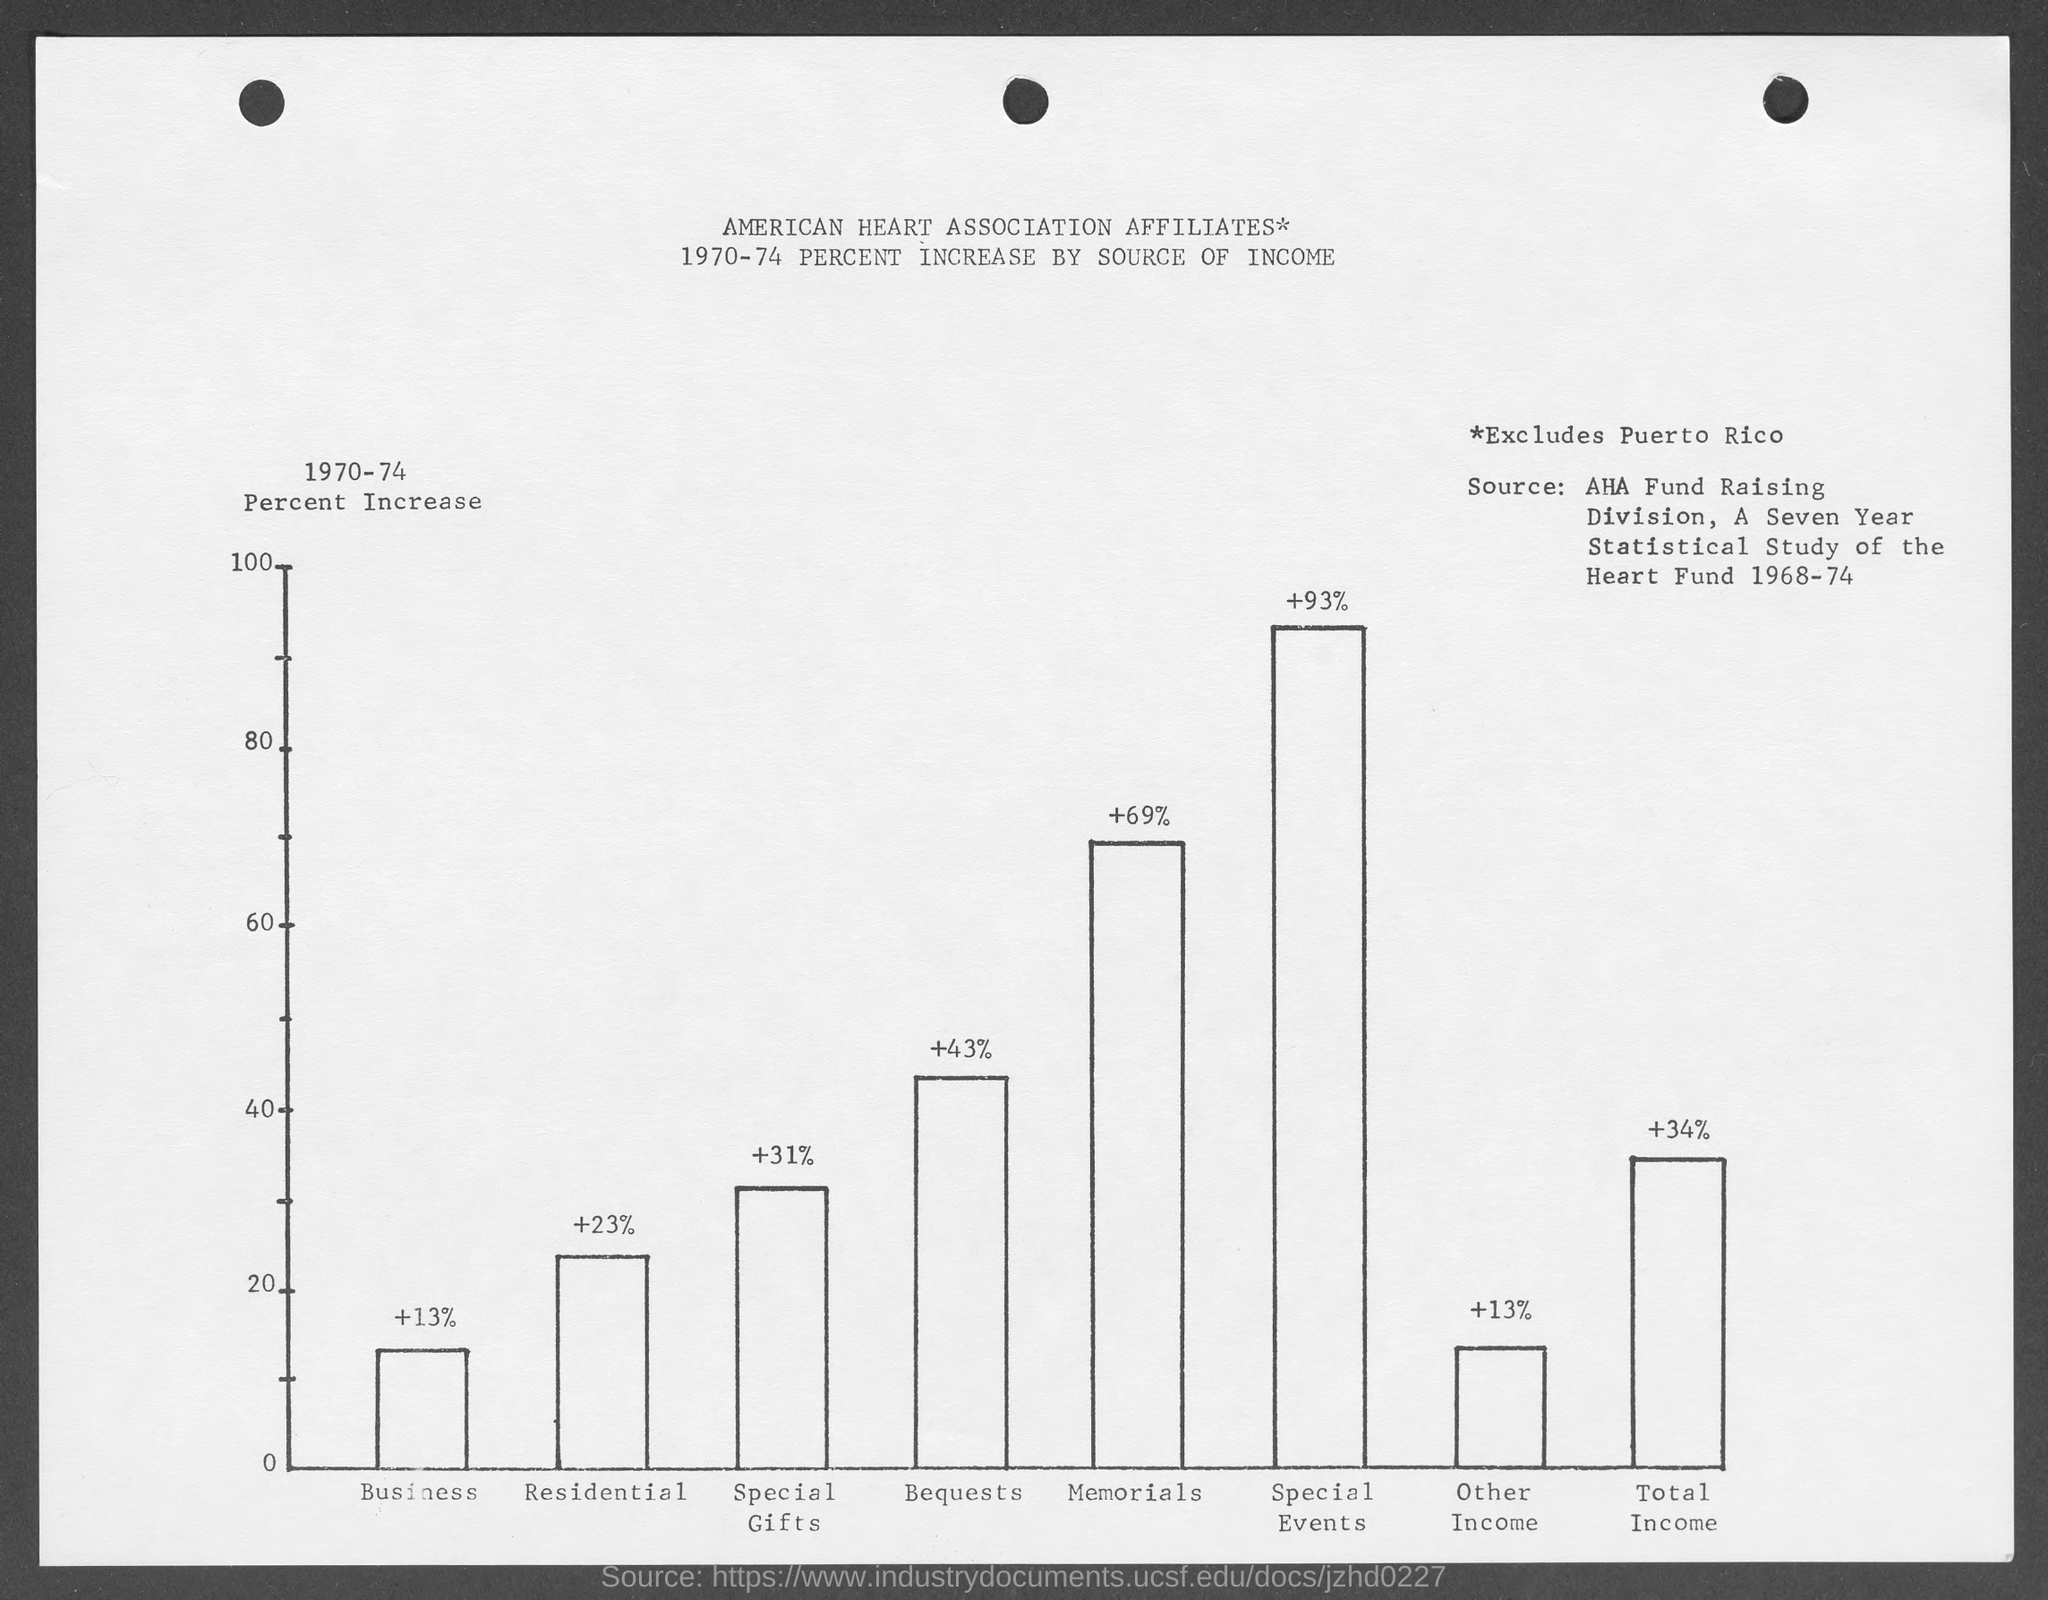What is the percentage increase by source of income of business from 1970-74 mentioned in the given graph ?
Offer a terse response. +13%. What is the percentage increase by source of income of residential from 1970-74 mentioned in the given graph ?
Your answer should be very brief. + 23 %. What is the percentage increase by source of income of special gifts from 1970-74 mentioned in the given graph ?
Offer a terse response. 31. What is the percentage increase by source of bequests  of business from 1970-74 mentioned in the given graph ?
Give a very brief answer. 43. What is the percentage increase by source of memorials of business from 1970-74 mentioned in the given graph ?
Offer a very short reply. + 69%. What is the percentage increase by source of special events of business from 1970-74 mentioned in the given graph ?
Offer a terse response. +93%. What is the percentage increase by source of other income  of business from 1970-74 mentioned in the given graph ?
Make the answer very short. 13. What is the percentage increase by source of total income  of business from 1970-74 mentioned in the given graph ?
Keep it short and to the point. +34%. 